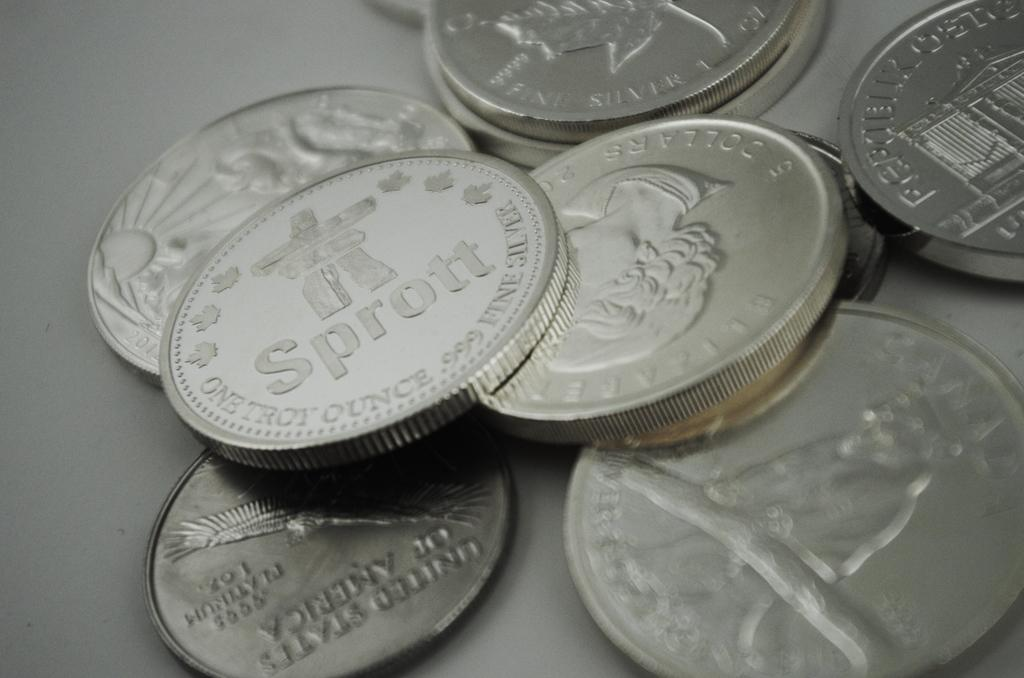Provide a one-sentence caption for the provided image. Silver coins stacked on top of each other one says Sprott. 